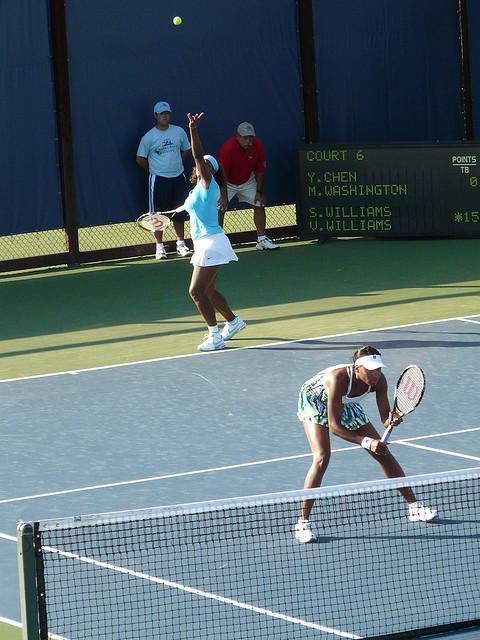How many people are visible?
Give a very brief answer. 4. 